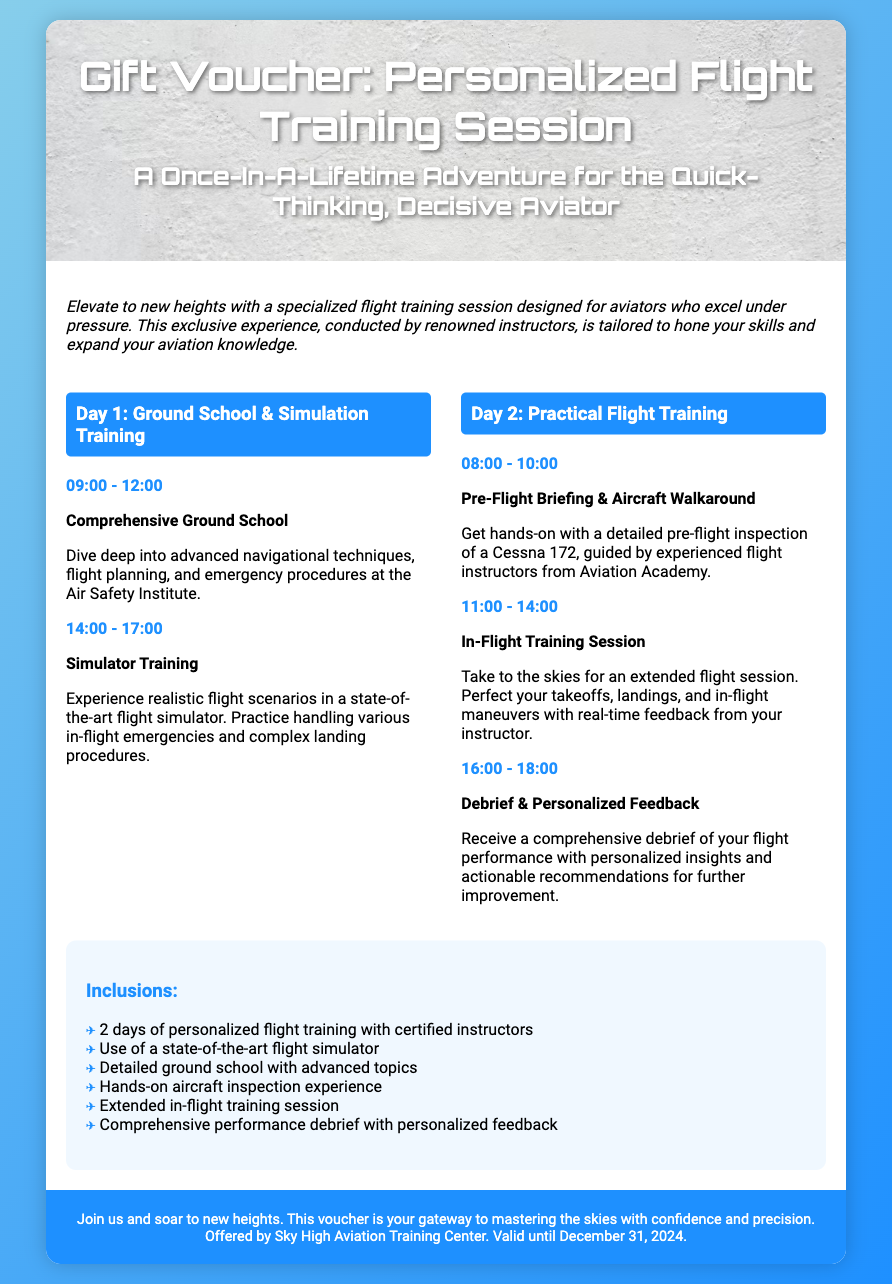What are the dates of the flight training session? The voucher includes a validity date until December 31, 2024, but it does not specify exact session dates.
Answer: December 31, 2024 How long is the flight training session? The document specifies two days of flight training.
Answer: 2 days What time does the simulator training start? The schedule indicates the simulator training starts at 14:00.
Answer: 14:00 What aircraft is used for the practical training session? The text mentions that the practical training session involves a Cessna 172.
Answer: Cessna 172 What do participants receive after the in-flight training session? The debrief section states that participants receive personalized feedback about their performance.
Answer: Personalized feedback What is included in the training program? The inclusions section lists various components of the training experience.
Answer: 2 days of personalized flight training with certified instructors Which institution is offering the training? The document lists Sky High Aviation Training Center as the provider of the training.
Answer: Sky High Aviation Training Center What is the main focus of the ground school sessions? The description emphasizes advanced navigational techniques and emergency procedures as key topics.
Answer: Advanced navigational techniques What type of training is provided on Day 1? The schedule specifies ground school and simulator training on Day 1.
Answer: Ground school & simulation training 